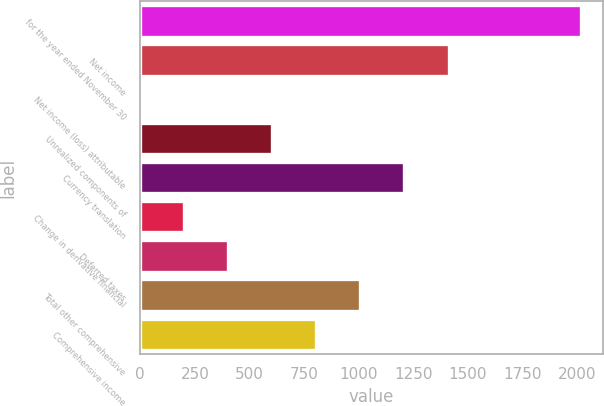Convert chart to OTSL. <chart><loc_0><loc_0><loc_500><loc_500><bar_chart><fcel>for the year ended November 30<fcel>Net income<fcel>Net income (loss) attributable<fcel>Unrealized components of<fcel>Currency translation<fcel>Change in derivative financial<fcel>Deferred taxes<fcel>Total other comprehensive<fcel>Comprehensive income<nl><fcel>2015<fcel>1410.65<fcel>0.5<fcel>604.85<fcel>1209.2<fcel>201.95<fcel>403.4<fcel>1007.75<fcel>806.3<nl></chart> 